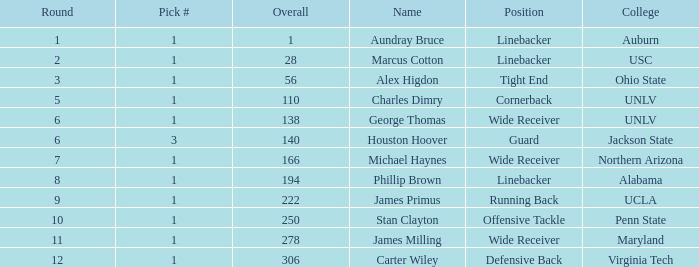What was the first Round with a Pick # greater than 1 and 140 Overall? None. 